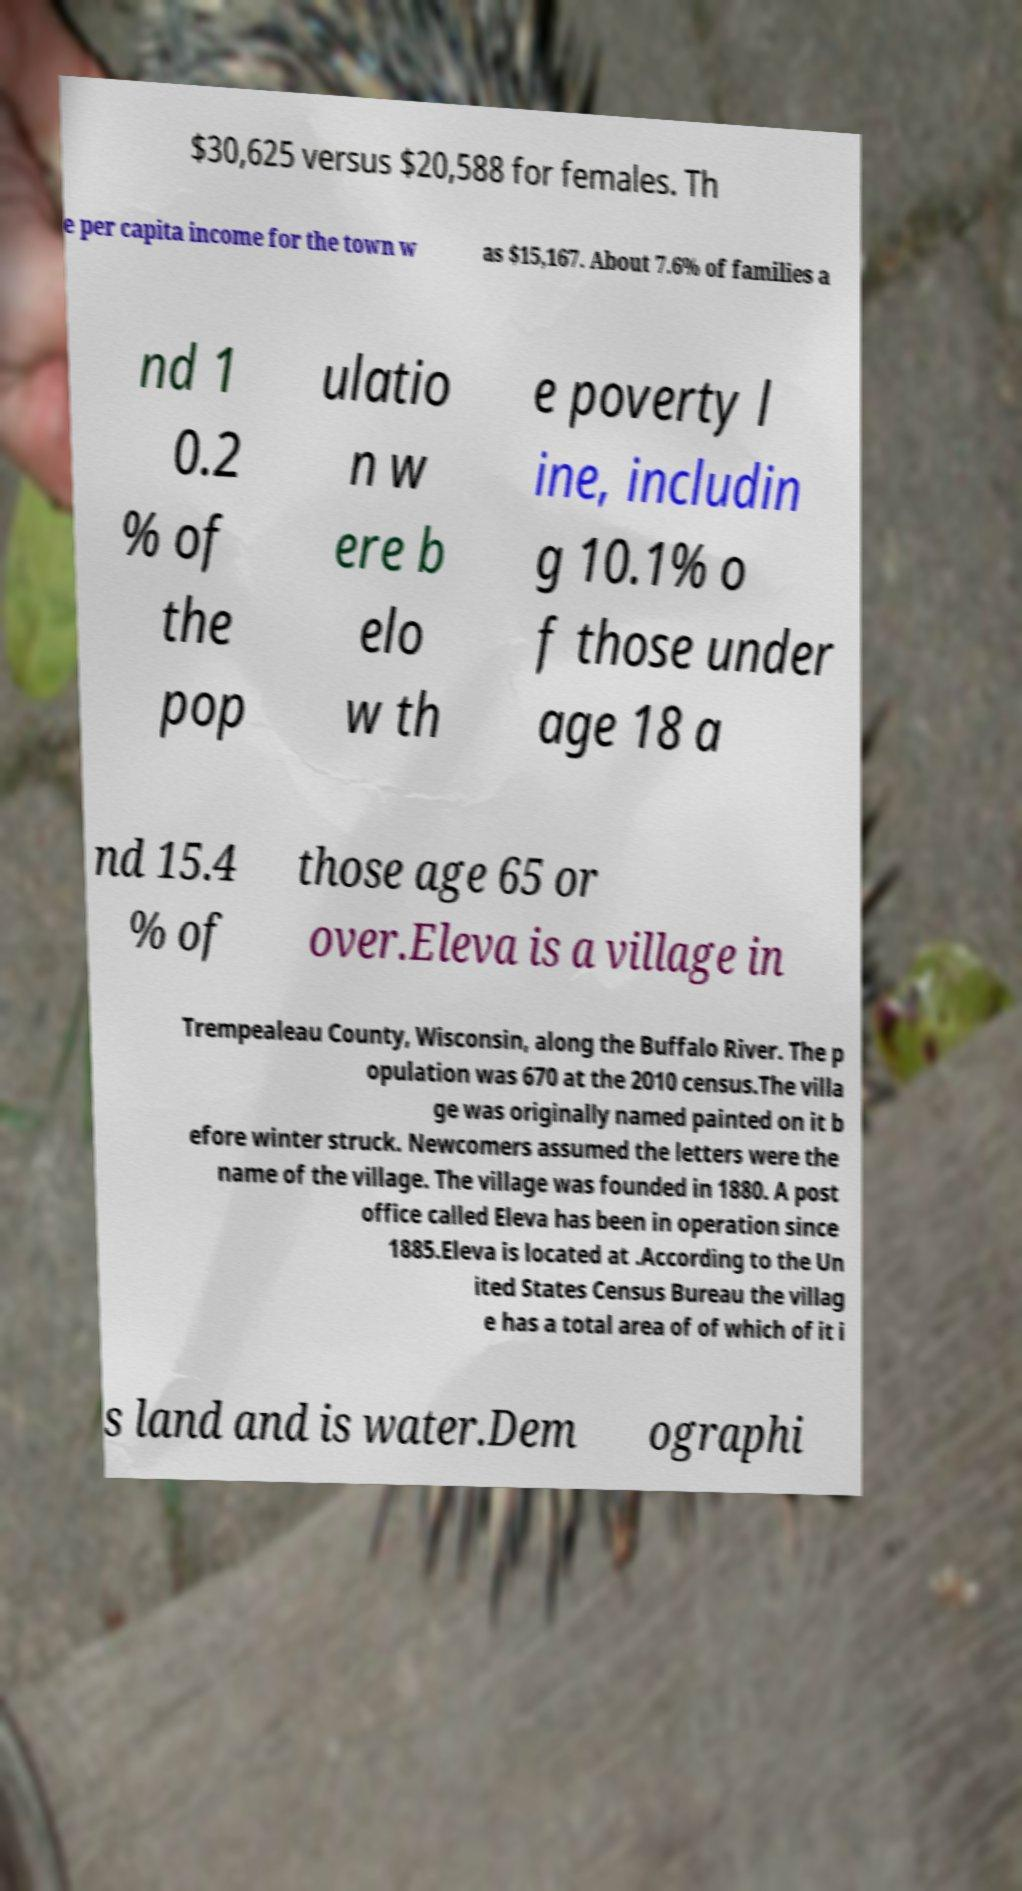Please identify and transcribe the text found in this image. $30,625 versus $20,588 for females. Th e per capita income for the town w as $15,167. About 7.6% of families a nd 1 0.2 % of the pop ulatio n w ere b elo w th e poverty l ine, includin g 10.1% o f those under age 18 a nd 15.4 % of those age 65 or over.Eleva is a village in Trempealeau County, Wisconsin, along the Buffalo River. The p opulation was 670 at the 2010 census.The villa ge was originally named painted on it b efore winter struck. Newcomers assumed the letters were the name of the village. The village was founded in 1880. A post office called Eleva has been in operation since 1885.Eleva is located at .According to the Un ited States Census Bureau the villag e has a total area of of which of it i s land and is water.Dem ographi 